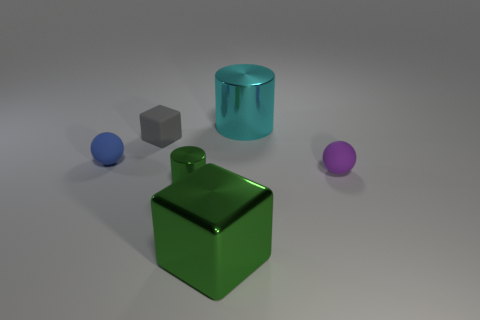Add 2 cyan objects. How many objects exist? 8 Subtract all cylinders. How many objects are left? 4 Add 4 green metal things. How many green metal things are left? 6 Add 6 small blocks. How many small blocks exist? 7 Subtract 1 green cubes. How many objects are left? 5 Subtract all yellow metallic cylinders. Subtract all big green things. How many objects are left? 5 